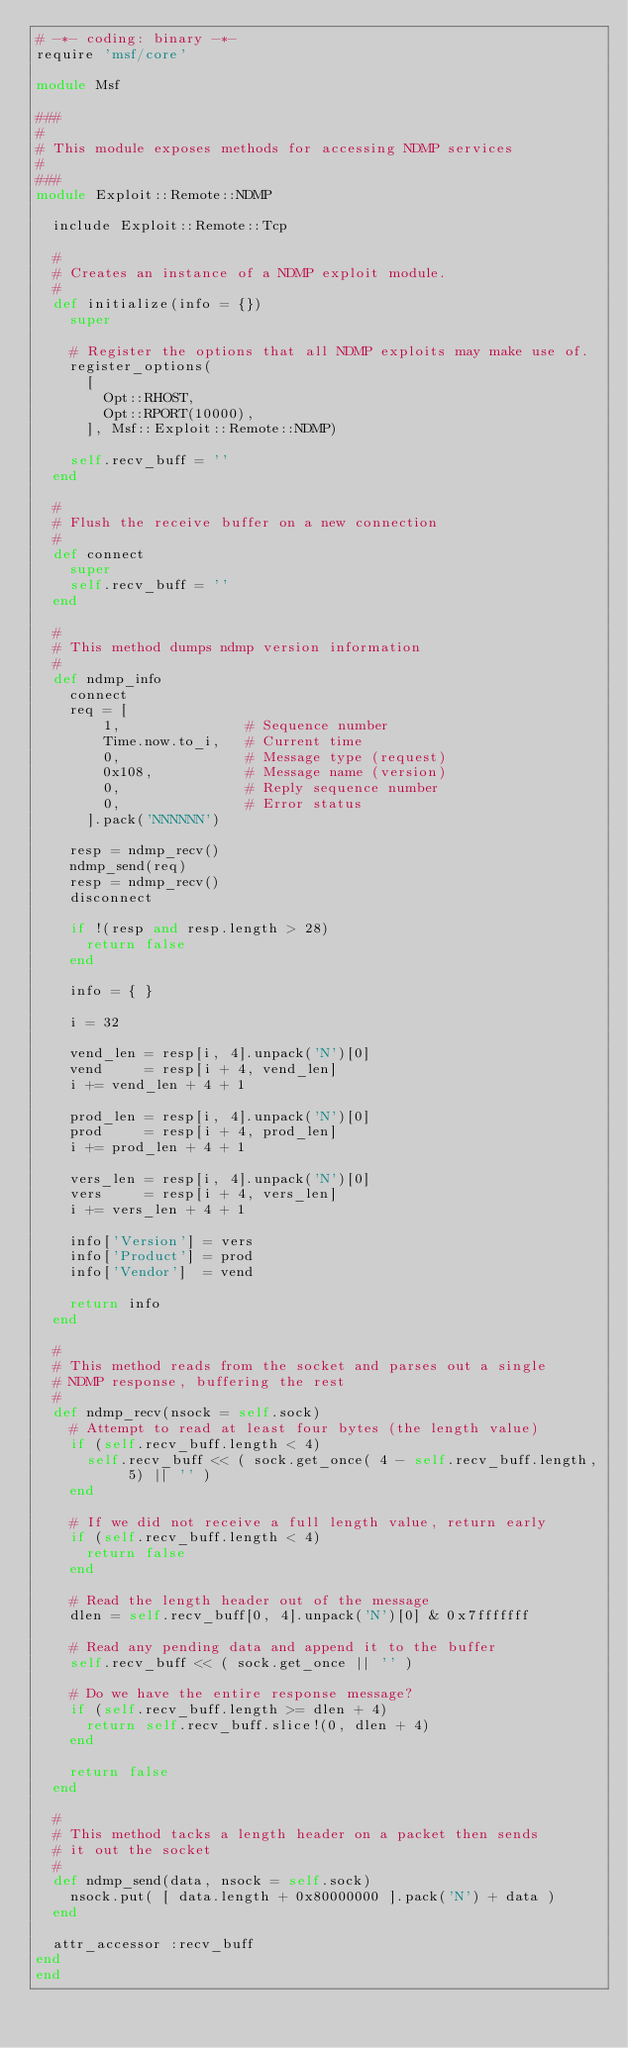Convert code to text. <code><loc_0><loc_0><loc_500><loc_500><_Ruby_># -*- coding: binary -*-
require 'msf/core'

module Msf

###
#
# This module exposes methods for accessing NDMP services
#
###
module Exploit::Remote::NDMP

  include Exploit::Remote::Tcp

  #
  # Creates an instance of a NDMP exploit module.
  #
  def initialize(info = {})
    super

    # Register the options that all NDMP exploits may make use of.
    register_options(
      [
        Opt::RHOST,
        Opt::RPORT(10000),
      ], Msf::Exploit::Remote::NDMP)

    self.recv_buff = ''
  end

  #
  # Flush the receive buffer on a new connection
  #
  def connect
    super
    self.recv_buff = ''
  end

  #
  # This method dumps ndmp version information
  #
  def ndmp_info
    connect
    req = [
        1,               # Sequence number
        Time.now.to_i,   # Current time
        0,               # Message type (request)
        0x108,           # Message name (version)
        0,               # Reply sequence number
        0,               # Error status
      ].pack('NNNNNN')

    resp = ndmp_recv()
    ndmp_send(req)
    resp = ndmp_recv()
    disconnect

    if !(resp and resp.length > 28)
      return false
    end

    info = { }

    i = 32

    vend_len = resp[i, 4].unpack('N')[0]
    vend     = resp[i + 4, vend_len]
    i += vend_len + 4 + 1

    prod_len = resp[i, 4].unpack('N')[0]
    prod     = resp[i + 4, prod_len]
    i += prod_len + 4 + 1

    vers_len = resp[i, 4].unpack('N')[0]
    vers     = resp[i + 4, vers_len]
    i += vers_len + 4 + 1

    info['Version'] = vers
    info['Product'] = prod
    info['Vendor']  = vend

    return info
  end

  #
  # This method reads from the socket and parses out a single
  # NDMP response, buffering the rest
  #
  def ndmp_recv(nsock = self.sock)
    # Attempt to read at least four bytes (the length value)
    if (self.recv_buff.length < 4)
      self.recv_buff << ( sock.get_once( 4 - self.recv_buff.length, 5) || '' )
    end

    # If we did not receive a full length value, return early
    if (self.recv_buff.length < 4)
      return false
    end

    # Read the length header out of the message
    dlen = self.recv_buff[0, 4].unpack('N')[0] & 0x7fffffff

    # Read any pending data and append it to the buffer
    self.recv_buff << ( sock.get_once || '' )

    # Do we have the entire response message?
    if (self.recv_buff.length >= dlen + 4)
      return self.recv_buff.slice!(0, dlen + 4)
    end

    return false
  end

  #
  # This method tacks a length header on a packet then sends
  # it out the socket
  #
  def ndmp_send(data, nsock = self.sock)
    nsock.put( [ data.length + 0x80000000 ].pack('N') + data )
  end

  attr_accessor	:recv_buff
end
end

</code> 